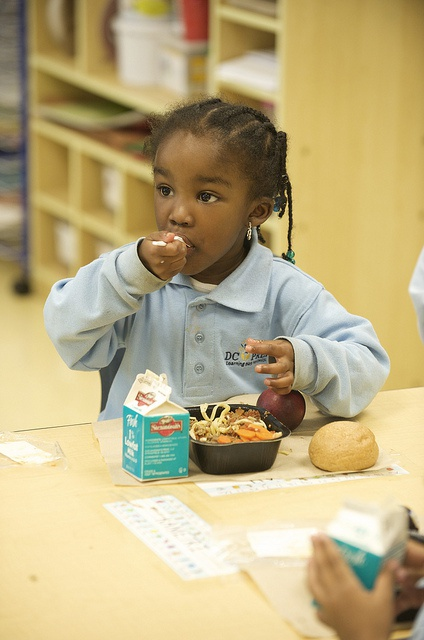Describe the objects in this image and their specific colors. I can see people in gray, darkgray, lightgray, maroon, and black tones, dining table in gray, khaki, ivory, and tan tones, people in gray, tan, and olive tones, bowl in gray, black, and orange tones, and apple in gray, maroon, black, and brown tones in this image. 